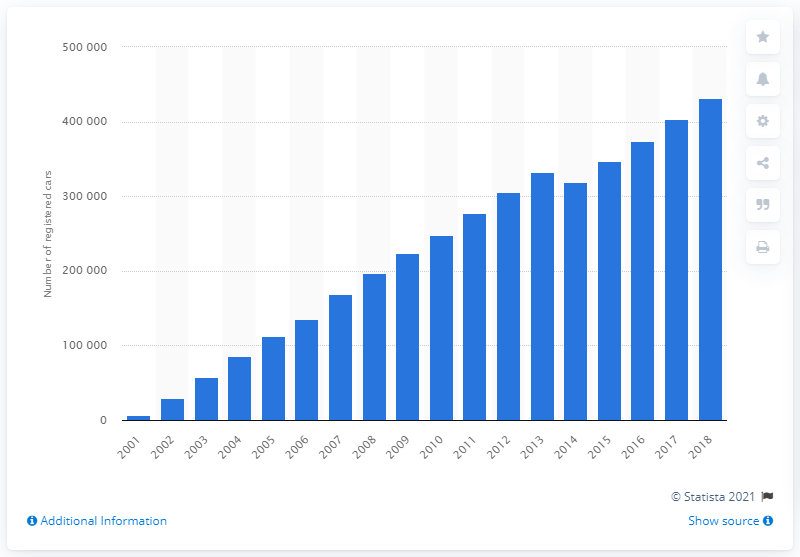List a handful of essential elements in this visual. By the end of 2018, a total of 431,737 Mini Cooper cars had been registered in Great Britain. 